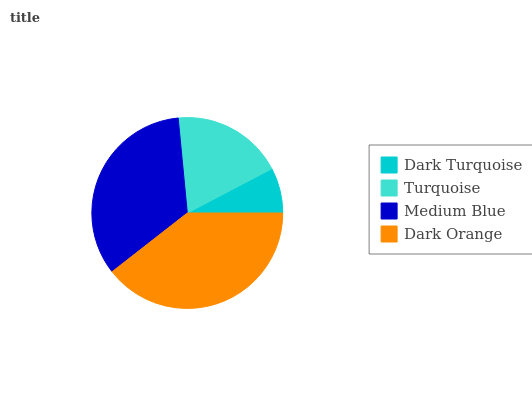Is Dark Turquoise the minimum?
Answer yes or no. Yes. Is Dark Orange the maximum?
Answer yes or no. Yes. Is Turquoise the minimum?
Answer yes or no. No. Is Turquoise the maximum?
Answer yes or no. No. Is Turquoise greater than Dark Turquoise?
Answer yes or no. Yes. Is Dark Turquoise less than Turquoise?
Answer yes or no. Yes. Is Dark Turquoise greater than Turquoise?
Answer yes or no. No. Is Turquoise less than Dark Turquoise?
Answer yes or no. No. Is Medium Blue the high median?
Answer yes or no. Yes. Is Turquoise the low median?
Answer yes or no. Yes. Is Turquoise the high median?
Answer yes or no. No. Is Medium Blue the low median?
Answer yes or no. No. 